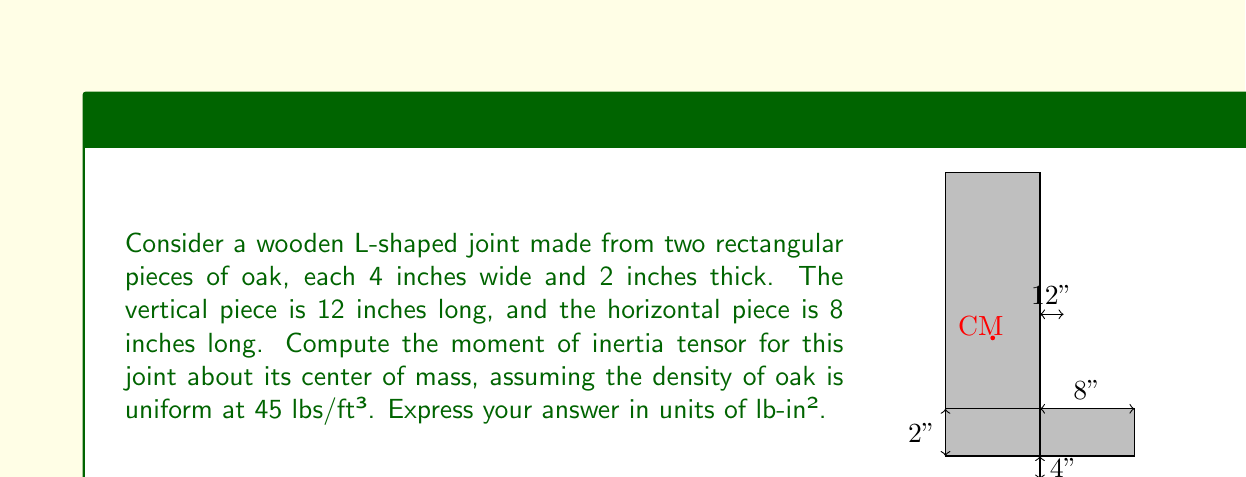Could you help me with this problem? To solve this problem, we'll follow these steps:

1) First, we need to find the center of mass (CM) of the L-shaped joint.
2) Then, we'll calculate the moment of inertia for each piece about its own CM.
3) Finally, we'll use the parallel axis theorem to find the moment of inertia about the joint's CM.

Step 1: Finding the Center of Mass

The total volume of the joint is:
$$ V = (12 \times 4 \times 2) + (8 \times 4 \times 2) = 160 \text{ in}^3 $$

The CM coordinates $(x_{CM}, y_{CM})$ from the bottom-left corner:

$$ x_{CM} = \frac{(12 \times 4 \times 2 \times 2) + (8 \times 4 \times 2 \times 4)}{160} = 2 \text{ in} $$
$$ y_{CM} = \frac{(12 \times 4 \times 2 \times 6) + (8 \times 4 \times 2 \times 1)}{160} = 5 \text{ in} $$

Step 2: Moment of Inertia for each piece about its CM

For a rectangular prism with dimensions $a$, $b$, and $c$:
$$ I_x = \frac{1}{12}m(b^2 + c^2) $$
$$ I_y = \frac{1}{12}m(a^2 + c^2) $$
$$ I_z = \frac{1}{12}m(a^2 + b^2) $$

The mass of each piece:
$$ m_1 = 45 \times \frac{12 \times 4 \times 2}{12^3} = 3 \text{ lbs} $$
$$ m_2 = 45 \times \frac{8 \times 4 \times 2}{12^3} = 2 \text{ lbs} $$

For the vertical piece (1):
$$ I_{1x} = \frac{1}{12} \times 3 \times (4^2 + 2^2) = 5 \text{ lb-in}^2 $$
$$ I_{1y} = \frac{1}{12} \times 3 \times (12^2 + 2^2) = 37 \text{ lb-in}^2 $$
$$ I_{1z} = \frac{1}{12} \times 3 \times (12^2 + 4^2) = 39 \text{ lb-in}^2 $$

For the horizontal piece (2):
$$ I_{2x} = \frac{1}{12} \times 2 \times (8^2 + 2^2) = 22.67 \text{ lb-in}^2 $$
$$ I_{2y} = \frac{1}{12} \times 2 \times (4^2 + 2^2) = 3.33 \text{ lb-in}^2 $$
$$ I_{2z} = \frac{1}{12} \times 2 \times (8^2 + 4^2) = 24 \text{ lb-in}^2 $$

Step 3: Parallel Axis Theorem

For the vertical piece:
$$ d_1 = \sqrt{2^2 + 1^2} = \sqrt{5} \text{ in} $$
$$ I_{1x'} = I_{1x} + m_1(1^2 + 1^2) = 5 + 3 \times 2 = 11 \text{ lb-in}^2 $$
$$ I_{1y'} = I_{1y} + m_1(2^2 + 1^2) = 37 + 3 \times 5 = 52 \text{ lb-in}^2 $$
$$ I_{1z'} = I_{1z} + m_1(2^2 + 1^2) = 39 + 3 \times 5 = 54 \text{ lb-in}^2 $$

For the horizontal piece:
$$ d_2 = \sqrt{2^2 + 4^2} = 2\sqrt{5} \text{ in} $$
$$ I_{2x'} = I_{2x} + m_2(4^2) = 22.67 + 2 \times 16 = 54.67 \text{ lb-in}^2 $$
$$ I_{2y'} = I_{2y} + m_2(2^2) = 3.33 + 2 \times 4 = 11.33 \text{ lb-in}^2 $$
$$ I_{2z'} = I_{2z} + m_2(2^2 + 4^2) = 24 + 2 \times 20 = 64 \text{ lb-in}^2 $$

The total moment of inertia tensor:
$$ I = \begin{bmatrix}
I_{x'} & -I_{xy'} & -I_{xz'} \\
-I_{xy'} & I_{y'} & -I_{yz'} \\
-I_{xz'} & -I_{yz'} & I_{z'}
\end{bmatrix} $$

Where:
$$ I_{x'} = I_{1x'} + I_{2x'} = 11 + 54.67 = 65.67 \text{ lb-in}^2 $$
$$ I_{y'} = I_{1y'} + I_{2y'} = 52 + 11.33 = 63.33 \text{ lb-in}^2 $$
$$ I_{z'} = I_{1z'} + I_{2z'} = 54 + 64 = 118 \text{ lb-in}^2 $$

The products of inertia are zero due to symmetry.
Answer: $$ I = \begin{bmatrix}
65.67 & 0 & 0 \\
0 & 63.33 & 0 \\
0 & 0 & 118
\end{bmatrix} \text{ lb-in}^2 $$ 